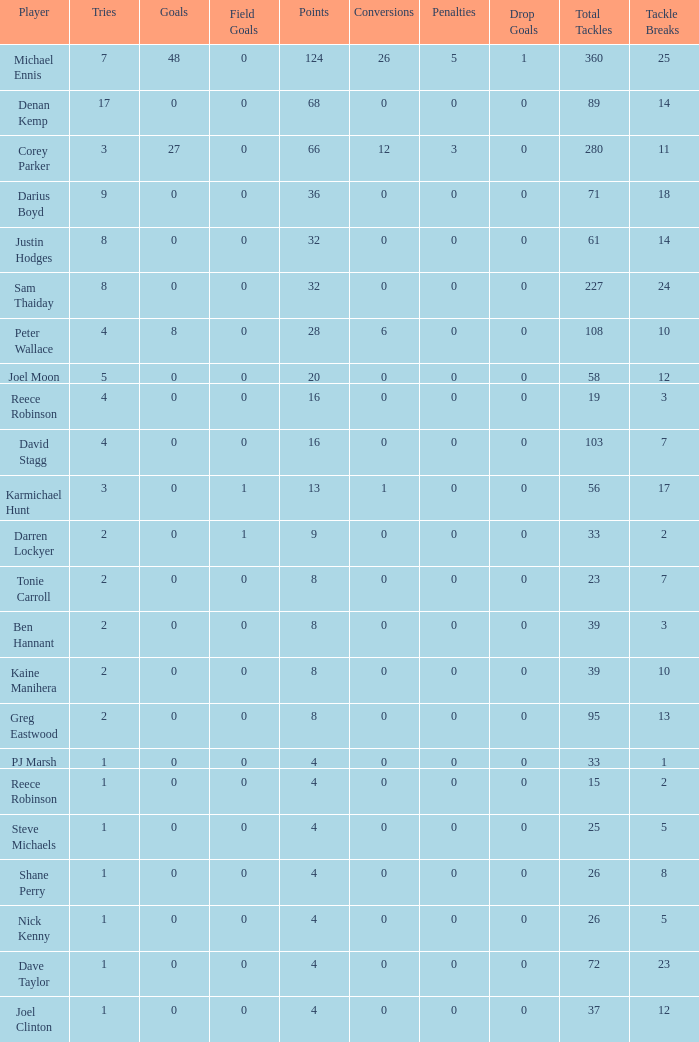What is the lowest tries the player with more than 0 goals, 28 points, and more than 0 field goals have? None. 